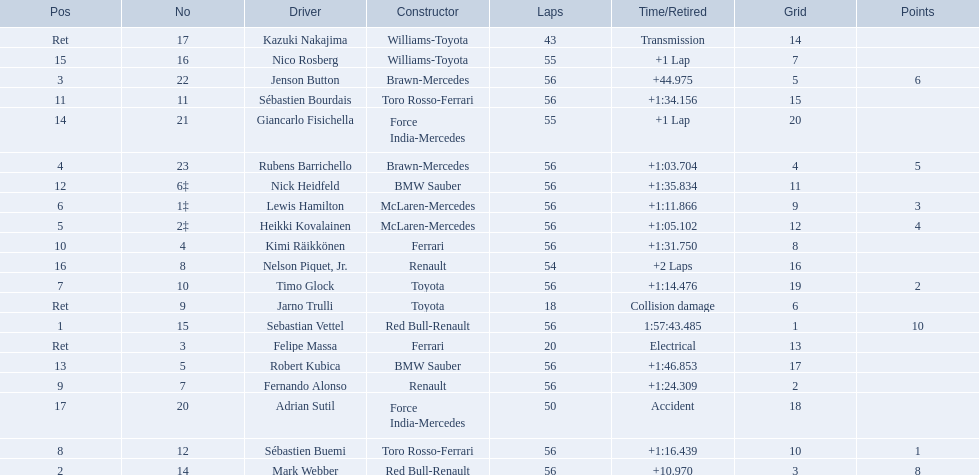Who were all the drivers? Sebastian Vettel, Mark Webber, Jenson Button, Rubens Barrichello, Heikki Kovalainen, Lewis Hamilton, Timo Glock, Sébastien Buemi, Fernando Alonso, Kimi Räikkönen, Sébastien Bourdais, Nick Heidfeld, Robert Kubica, Giancarlo Fisichella, Nico Rosberg, Nelson Piquet, Jr., Adrian Sutil, Kazuki Nakajima, Felipe Massa, Jarno Trulli. Which of these didn't have ferrari as a constructor? Sebastian Vettel, Mark Webber, Jenson Button, Rubens Barrichello, Heikki Kovalainen, Lewis Hamilton, Timo Glock, Sébastien Buemi, Fernando Alonso, Sébastien Bourdais, Nick Heidfeld, Robert Kubica, Giancarlo Fisichella, Nico Rosberg, Nelson Piquet, Jr., Adrian Sutil, Kazuki Nakajima, Jarno Trulli. Which of these was in first place? Sebastian Vettel. 